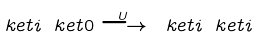<formula> <loc_0><loc_0><loc_500><loc_500>\ k e t { i } \ k e t { 0 } \stackrel { U } { \longrightarrow } \ k e t { i } \ k e t { i }</formula> 